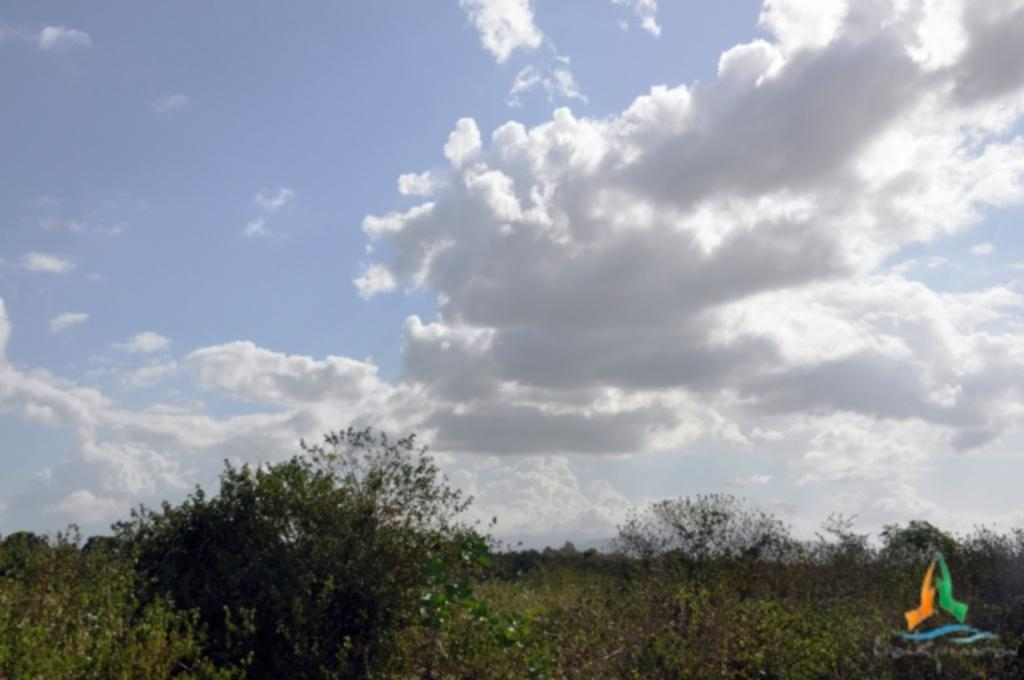What is located on the bottom right side of the image? There is an image on the bottom right side of the image. What type of vegetation can be seen in the image? There are trees, bushes, plants, and grass in the image. What is visible in the background of the image? The sky is visible in the background of the image. What is the condition of the sky in the image? The sky appears to be cloudy in the image. Where is the ant carrying the toy in the image? There is no ant or toy present in the image. What type of map can be seen in the image? There is no map present in the image. 